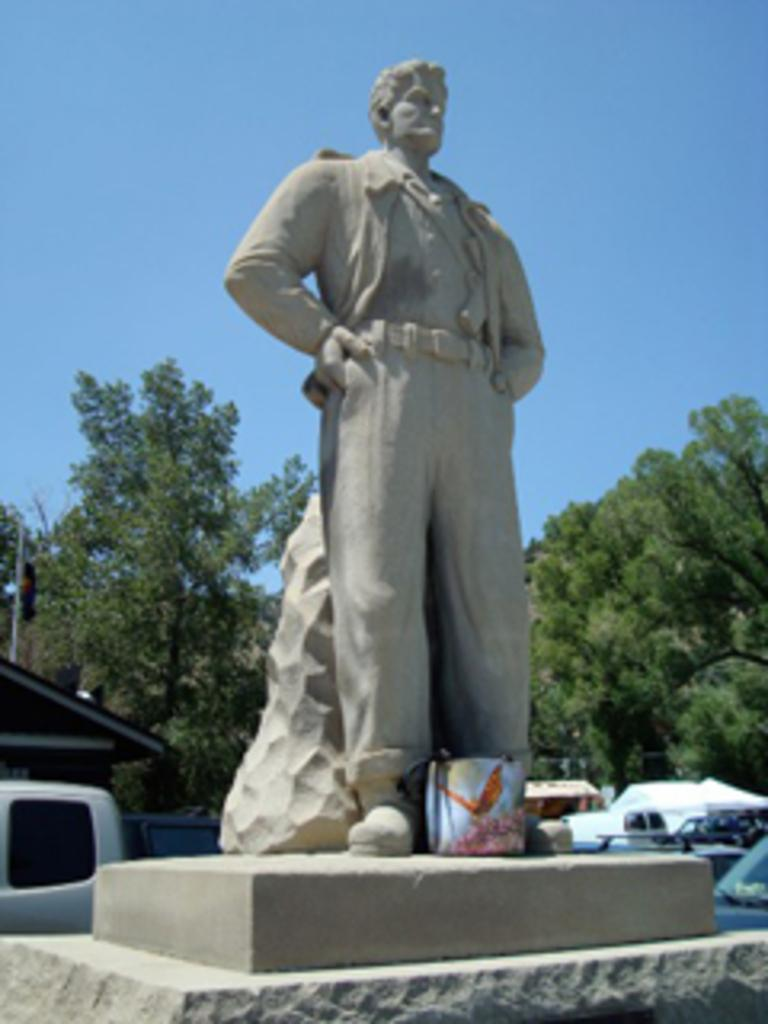What is the main subject of the image? There is a statue of a man in the image. What can be seen behind the statue? There are trees behind the statue in the image. Are there any islands visible in the image? There is no island present in the image; it features a statue of a man with trees in the background. Can you see any police officers in the image? There is no police officer present in the image. 